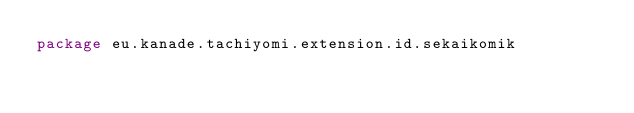<code> <loc_0><loc_0><loc_500><loc_500><_Kotlin_>package eu.kanade.tachiyomi.extension.id.sekaikomik
</code> 